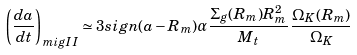Convert formula to latex. <formula><loc_0><loc_0><loc_500><loc_500>\left ( \frac { d a } { d t } \right ) _ { m i g I I } \simeq 3 s i g n ( a - R _ { m } ) \alpha \frac { \Sigma _ { g } ( R _ { m } ) R _ { m } ^ { 2 } } { M _ { t } } \, \frac { \Omega _ { K } ( R _ { m } ) } { \Omega _ { K } }</formula> 